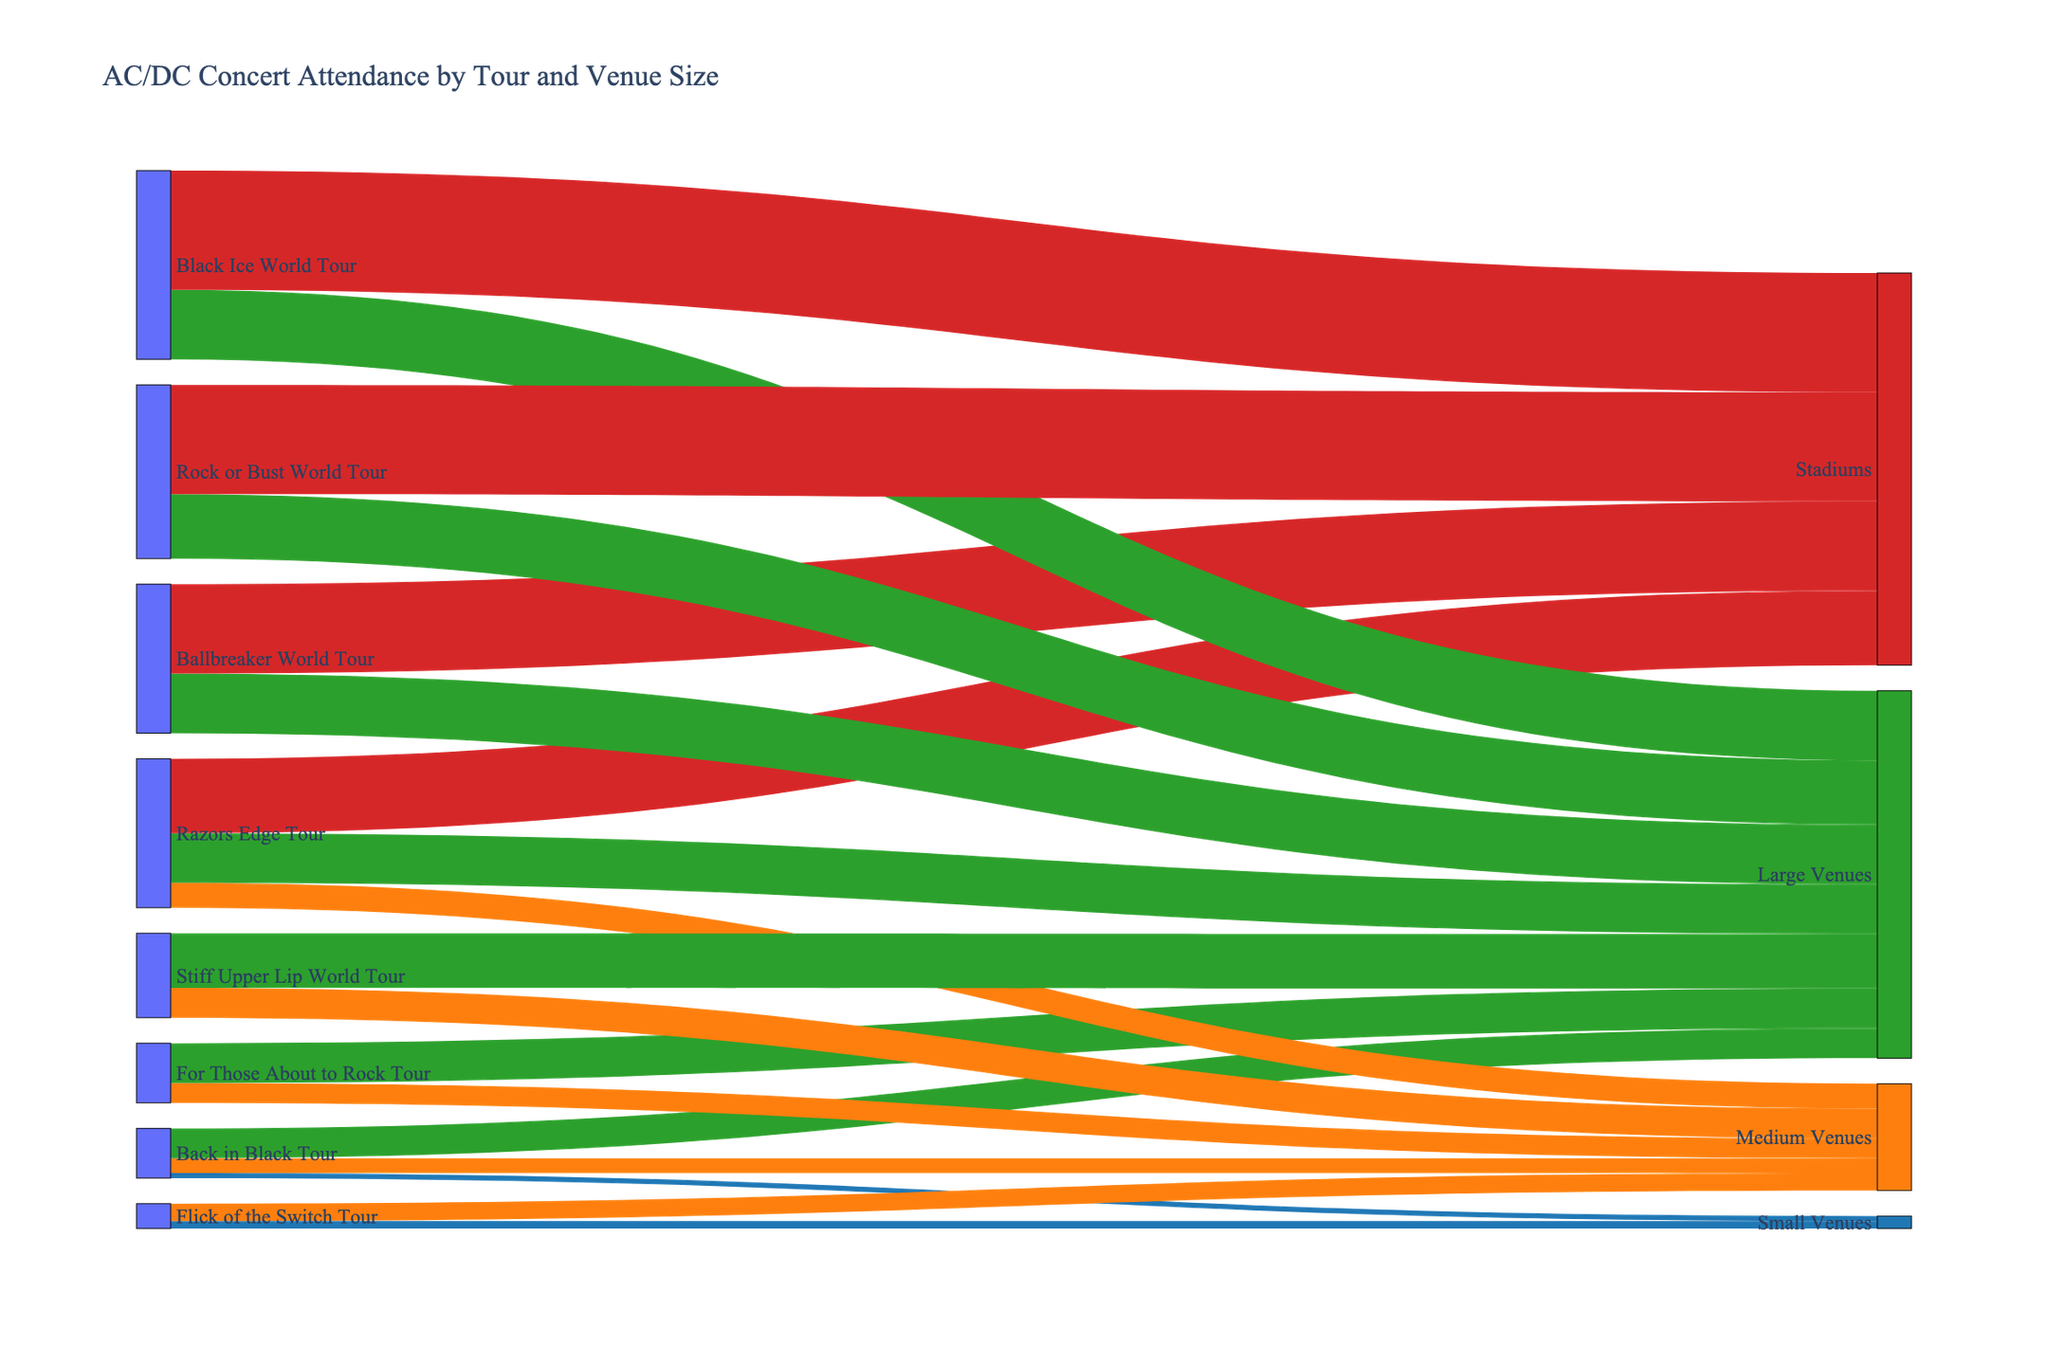Which tour had the highest concert attendance in large venues? To determine the highest concert attendance in large venues, look at the links labeled "Large Venues" and compare the values for each tour. The highest value is associated with the "Black Ice World Tour" which had 700,000 attendees.
Answer: Black Ice World Tour How many tours included performances at medium venues? Identify all unique tours connected to "Medium Venues". The tours connected to medium venues are "Back in Black Tour", "For Those About to Rock Tour", "Flick of the Switch Tour", "Razors Edge Tour", "Stiff Upper Lip World Tour". There are 5 tours in total.
Answer: 5 Compare concert attendance between the "Razors Edge Tour" and "Ballbreaker World Tour" for stadiums. Look at the links from "Razors Edge Tour" and "Ballbreaker World Tour" to "Stadiums". The "Razors Edge Tour" had 750,000 attendees and the "Ballbreaker World Tour" had 900,000 attendees at stadiums.
Answer: Ballbreaker World Tour had more attendees What was the total attendance for the "Back in Black Tour"? Sum up the values for "Back in Black Tour" across all venue sizes. The values are 50,000 (Small Venues), 150,000 (Medium Venues), and 300,000 (Large Venues). The total attendance is 50,000 + 150,000 + 300,000 = 500,000.
Answer: 500,000 Which venue type had the highest overall concert attendance across all tours? Sum up the values for each venue size across all tours. Small Venues (50,000 + 75,000 = 125,000), Medium Venues (150,000 + 200,000 + 175,000 + 250,000 + 300,000, = 1,075,000), Large Venues (300,000 + 400,000 + 600,000 + 550,000 + 700,000+ 650,000 = 2,800,000), Stadiums (750,000 + 900,000 + 1,200,000 + 1,100,000 = 3,950,000). Stadiums have the highest overall concert attendance.
Answer: Stadiums Identify which tour had zero small venue performances. Look for tours where no connections link to "Small Venues". Tours without "Small Venues" are "For Those About to Rock Tour", "Razors Edge Tour", "Ballbreaker World Tour", "Stiff Upper Lip World Tour", "Black Ice World Tour", "Rock or Bust World Tour". The list is slightly long, but the answer criteria match it.
Answer: For Those About to Rock Tour, Razors Edge Tour, Ballbreaker World Tour, Stiff Upper Lip World Tour, Black Ice World Tour, Rock or Bust World Tour 